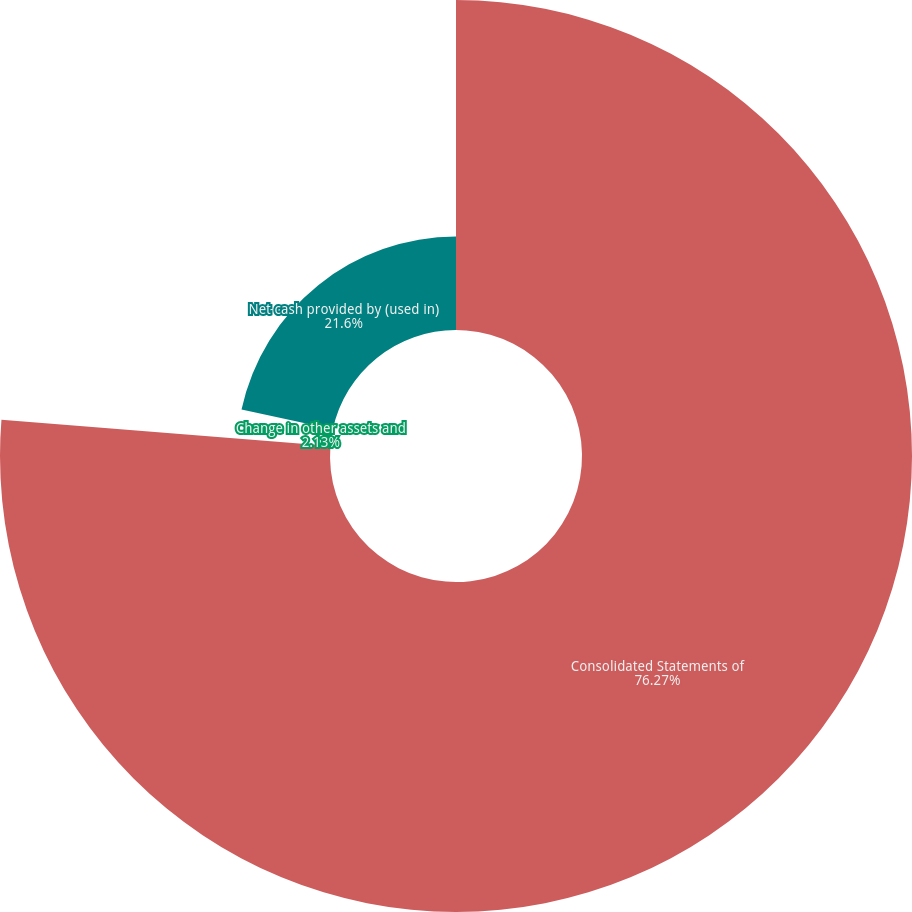<chart> <loc_0><loc_0><loc_500><loc_500><pie_chart><fcel>Consolidated Statements of<fcel>Change in other assets and<fcel>Net cash provided by (used in)<nl><fcel>76.27%<fcel>2.13%<fcel>21.6%<nl></chart> 